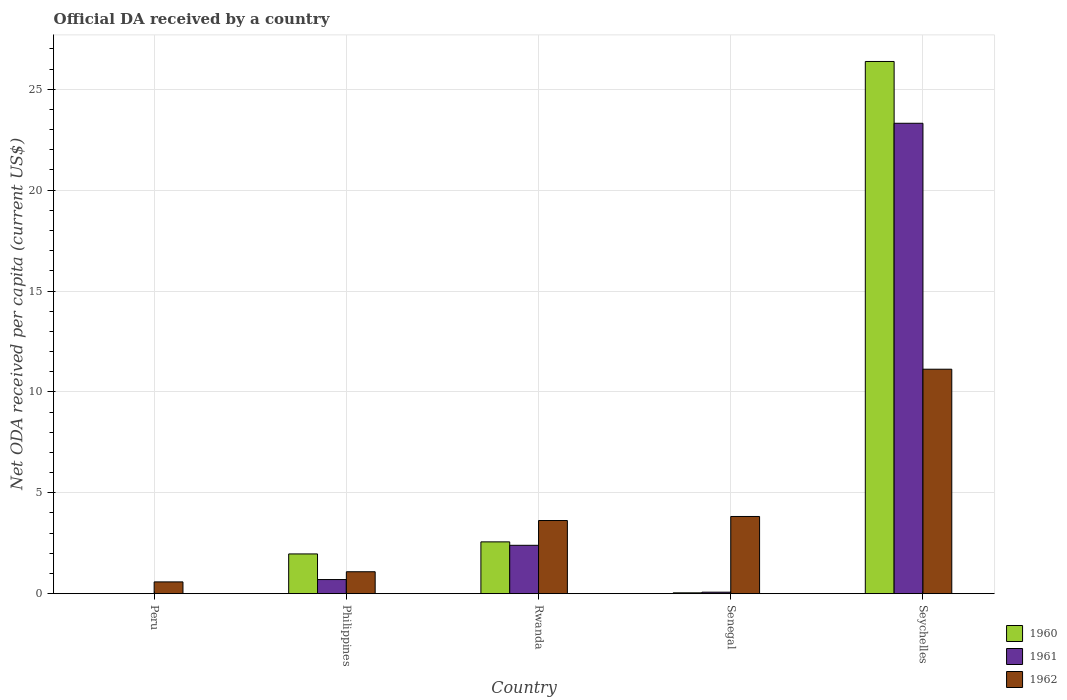How many different coloured bars are there?
Offer a very short reply. 3. What is the label of the 5th group of bars from the left?
Offer a very short reply. Seychelles. In how many cases, is the number of bars for a given country not equal to the number of legend labels?
Keep it short and to the point. 1. What is the ODA received in in 1962 in Seychelles?
Ensure brevity in your answer.  11.13. Across all countries, what is the maximum ODA received in in 1961?
Offer a very short reply. 23.32. In which country was the ODA received in in 1960 maximum?
Ensure brevity in your answer.  Seychelles. What is the total ODA received in in 1961 in the graph?
Provide a short and direct response. 26.49. What is the difference between the ODA received in in 1961 in Philippines and that in Senegal?
Your answer should be compact. 0.63. What is the difference between the ODA received in in 1961 in Senegal and the ODA received in in 1960 in Seychelles?
Your answer should be very brief. -26.31. What is the average ODA received in in 1960 per country?
Make the answer very short. 6.19. What is the difference between the ODA received in of/in 1962 and ODA received in of/in 1961 in Philippines?
Your answer should be compact. 0.39. What is the ratio of the ODA received in in 1962 in Philippines to that in Seychelles?
Offer a very short reply. 0.1. Is the difference between the ODA received in in 1962 in Philippines and Rwanda greater than the difference between the ODA received in in 1961 in Philippines and Rwanda?
Your answer should be very brief. No. What is the difference between the highest and the second highest ODA received in in 1962?
Provide a succinct answer. 0.2. What is the difference between the highest and the lowest ODA received in in 1960?
Give a very brief answer. 26.38. In how many countries, is the ODA received in in 1961 greater than the average ODA received in in 1961 taken over all countries?
Make the answer very short. 1. Is it the case that in every country, the sum of the ODA received in in 1962 and ODA received in in 1961 is greater than the ODA received in in 1960?
Give a very brief answer. No. How many bars are there?
Offer a very short reply. 13. Are all the bars in the graph horizontal?
Provide a succinct answer. No. How many countries are there in the graph?
Keep it short and to the point. 5. Does the graph contain any zero values?
Make the answer very short. Yes. Does the graph contain grids?
Ensure brevity in your answer.  Yes. Where does the legend appear in the graph?
Your response must be concise. Bottom right. How many legend labels are there?
Your response must be concise. 3. What is the title of the graph?
Make the answer very short. Official DA received by a country. What is the label or title of the Y-axis?
Keep it short and to the point. Net ODA received per capita (current US$). What is the Net ODA received per capita (current US$) of 1960 in Peru?
Offer a very short reply. 0. What is the Net ODA received per capita (current US$) of 1961 in Peru?
Keep it short and to the point. 0. What is the Net ODA received per capita (current US$) in 1962 in Peru?
Provide a short and direct response. 0.58. What is the Net ODA received per capita (current US$) in 1960 in Philippines?
Your answer should be very brief. 1.97. What is the Net ODA received per capita (current US$) of 1961 in Philippines?
Provide a short and direct response. 0.7. What is the Net ODA received per capita (current US$) in 1962 in Philippines?
Ensure brevity in your answer.  1.09. What is the Net ODA received per capita (current US$) of 1960 in Rwanda?
Ensure brevity in your answer.  2.57. What is the Net ODA received per capita (current US$) of 1961 in Rwanda?
Provide a short and direct response. 2.4. What is the Net ODA received per capita (current US$) in 1962 in Rwanda?
Your answer should be compact. 3.63. What is the Net ODA received per capita (current US$) in 1960 in Senegal?
Your response must be concise. 0.04. What is the Net ODA received per capita (current US$) of 1961 in Senegal?
Provide a succinct answer. 0.07. What is the Net ODA received per capita (current US$) of 1962 in Senegal?
Provide a succinct answer. 3.83. What is the Net ODA received per capita (current US$) in 1960 in Seychelles?
Your answer should be very brief. 26.38. What is the Net ODA received per capita (current US$) of 1961 in Seychelles?
Provide a short and direct response. 23.32. What is the Net ODA received per capita (current US$) of 1962 in Seychelles?
Your answer should be compact. 11.13. Across all countries, what is the maximum Net ODA received per capita (current US$) in 1960?
Make the answer very short. 26.38. Across all countries, what is the maximum Net ODA received per capita (current US$) of 1961?
Provide a succinct answer. 23.32. Across all countries, what is the maximum Net ODA received per capita (current US$) in 1962?
Ensure brevity in your answer.  11.13. Across all countries, what is the minimum Net ODA received per capita (current US$) in 1961?
Provide a short and direct response. 0. Across all countries, what is the minimum Net ODA received per capita (current US$) of 1962?
Keep it short and to the point. 0.58. What is the total Net ODA received per capita (current US$) of 1960 in the graph?
Your answer should be compact. 30.96. What is the total Net ODA received per capita (current US$) in 1961 in the graph?
Offer a very short reply. 26.49. What is the total Net ODA received per capita (current US$) of 1962 in the graph?
Keep it short and to the point. 20.25. What is the difference between the Net ODA received per capita (current US$) of 1962 in Peru and that in Philippines?
Ensure brevity in your answer.  -0.5. What is the difference between the Net ODA received per capita (current US$) of 1962 in Peru and that in Rwanda?
Your answer should be very brief. -3.04. What is the difference between the Net ODA received per capita (current US$) in 1962 in Peru and that in Senegal?
Provide a short and direct response. -3.24. What is the difference between the Net ODA received per capita (current US$) of 1962 in Peru and that in Seychelles?
Your response must be concise. -10.54. What is the difference between the Net ODA received per capita (current US$) in 1960 in Philippines and that in Rwanda?
Provide a short and direct response. -0.6. What is the difference between the Net ODA received per capita (current US$) of 1961 in Philippines and that in Rwanda?
Ensure brevity in your answer.  -1.7. What is the difference between the Net ODA received per capita (current US$) in 1962 in Philippines and that in Rwanda?
Your response must be concise. -2.54. What is the difference between the Net ODA received per capita (current US$) of 1960 in Philippines and that in Senegal?
Provide a short and direct response. 1.93. What is the difference between the Net ODA received per capita (current US$) of 1961 in Philippines and that in Senegal?
Your answer should be compact. 0.63. What is the difference between the Net ODA received per capita (current US$) in 1962 in Philippines and that in Senegal?
Offer a very short reply. -2.74. What is the difference between the Net ODA received per capita (current US$) of 1960 in Philippines and that in Seychelles?
Offer a very short reply. -24.41. What is the difference between the Net ODA received per capita (current US$) in 1961 in Philippines and that in Seychelles?
Provide a short and direct response. -22.62. What is the difference between the Net ODA received per capita (current US$) in 1962 in Philippines and that in Seychelles?
Provide a succinct answer. -10.04. What is the difference between the Net ODA received per capita (current US$) of 1960 in Rwanda and that in Senegal?
Your answer should be compact. 2.53. What is the difference between the Net ODA received per capita (current US$) in 1961 in Rwanda and that in Senegal?
Make the answer very short. 2.32. What is the difference between the Net ODA received per capita (current US$) of 1962 in Rwanda and that in Senegal?
Make the answer very short. -0.2. What is the difference between the Net ODA received per capita (current US$) of 1960 in Rwanda and that in Seychelles?
Ensure brevity in your answer.  -23.81. What is the difference between the Net ODA received per capita (current US$) in 1961 in Rwanda and that in Seychelles?
Give a very brief answer. -20.92. What is the difference between the Net ODA received per capita (current US$) in 1962 in Rwanda and that in Seychelles?
Provide a short and direct response. -7.5. What is the difference between the Net ODA received per capita (current US$) of 1960 in Senegal and that in Seychelles?
Provide a succinct answer. -26.34. What is the difference between the Net ODA received per capita (current US$) in 1961 in Senegal and that in Seychelles?
Make the answer very short. -23.24. What is the difference between the Net ODA received per capita (current US$) of 1962 in Senegal and that in Seychelles?
Offer a very short reply. -7.3. What is the difference between the Net ODA received per capita (current US$) of 1960 in Philippines and the Net ODA received per capita (current US$) of 1961 in Rwanda?
Your response must be concise. -0.43. What is the difference between the Net ODA received per capita (current US$) of 1960 in Philippines and the Net ODA received per capita (current US$) of 1962 in Rwanda?
Your answer should be very brief. -1.66. What is the difference between the Net ODA received per capita (current US$) of 1961 in Philippines and the Net ODA received per capita (current US$) of 1962 in Rwanda?
Provide a succinct answer. -2.93. What is the difference between the Net ODA received per capita (current US$) in 1960 in Philippines and the Net ODA received per capita (current US$) in 1961 in Senegal?
Provide a short and direct response. 1.9. What is the difference between the Net ODA received per capita (current US$) in 1960 in Philippines and the Net ODA received per capita (current US$) in 1962 in Senegal?
Your answer should be very brief. -1.86. What is the difference between the Net ODA received per capita (current US$) in 1961 in Philippines and the Net ODA received per capita (current US$) in 1962 in Senegal?
Offer a very short reply. -3.13. What is the difference between the Net ODA received per capita (current US$) in 1960 in Philippines and the Net ODA received per capita (current US$) in 1961 in Seychelles?
Your answer should be compact. -21.35. What is the difference between the Net ODA received per capita (current US$) in 1960 in Philippines and the Net ODA received per capita (current US$) in 1962 in Seychelles?
Offer a very short reply. -9.16. What is the difference between the Net ODA received per capita (current US$) in 1961 in Philippines and the Net ODA received per capita (current US$) in 1962 in Seychelles?
Offer a very short reply. -10.43. What is the difference between the Net ODA received per capita (current US$) in 1960 in Rwanda and the Net ODA received per capita (current US$) in 1961 in Senegal?
Your answer should be compact. 2.49. What is the difference between the Net ODA received per capita (current US$) in 1960 in Rwanda and the Net ODA received per capita (current US$) in 1962 in Senegal?
Provide a succinct answer. -1.26. What is the difference between the Net ODA received per capita (current US$) in 1961 in Rwanda and the Net ODA received per capita (current US$) in 1962 in Senegal?
Offer a very short reply. -1.43. What is the difference between the Net ODA received per capita (current US$) of 1960 in Rwanda and the Net ODA received per capita (current US$) of 1961 in Seychelles?
Make the answer very short. -20.75. What is the difference between the Net ODA received per capita (current US$) in 1960 in Rwanda and the Net ODA received per capita (current US$) in 1962 in Seychelles?
Your answer should be compact. -8.56. What is the difference between the Net ODA received per capita (current US$) in 1961 in Rwanda and the Net ODA received per capita (current US$) in 1962 in Seychelles?
Give a very brief answer. -8.73. What is the difference between the Net ODA received per capita (current US$) of 1960 in Senegal and the Net ODA received per capita (current US$) of 1961 in Seychelles?
Offer a very short reply. -23.28. What is the difference between the Net ODA received per capita (current US$) of 1960 in Senegal and the Net ODA received per capita (current US$) of 1962 in Seychelles?
Your response must be concise. -11.08. What is the difference between the Net ODA received per capita (current US$) of 1961 in Senegal and the Net ODA received per capita (current US$) of 1962 in Seychelles?
Provide a short and direct response. -11.05. What is the average Net ODA received per capita (current US$) in 1960 per country?
Provide a succinct answer. 6.19. What is the average Net ODA received per capita (current US$) in 1961 per country?
Provide a succinct answer. 5.3. What is the average Net ODA received per capita (current US$) of 1962 per country?
Give a very brief answer. 4.05. What is the difference between the Net ODA received per capita (current US$) in 1960 and Net ODA received per capita (current US$) in 1961 in Philippines?
Your answer should be very brief. 1.27. What is the difference between the Net ODA received per capita (current US$) of 1960 and Net ODA received per capita (current US$) of 1962 in Philippines?
Provide a short and direct response. 0.88. What is the difference between the Net ODA received per capita (current US$) of 1961 and Net ODA received per capita (current US$) of 1962 in Philippines?
Offer a very short reply. -0.39. What is the difference between the Net ODA received per capita (current US$) in 1960 and Net ODA received per capita (current US$) in 1961 in Rwanda?
Offer a very short reply. 0.17. What is the difference between the Net ODA received per capita (current US$) in 1960 and Net ODA received per capita (current US$) in 1962 in Rwanda?
Give a very brief answer. -1.06. What is the difference between the Net ODA received per capita (current US$) in 1961 and Net ODA received per capita (current US$) in 1962 in Rwanda?
Your response must be concise. -1.23. What is the difference between the Net ODA received per capita (current US$) of 1960 and Net ODA received per capita (current US$) of 1961 in Senegal?
Make the answer very short. -0.03. What is the difference between the Net ODA received per capita (current US$) in 1960 and Net ODA received per capita (current US$) in 1962 in Senegal?
Make the answer very short. -3.78. What is the difference between the Net ODA received per capita (current US$) in 1961 and Net ODA received per capita (current US$) in 1962 in Senegal?
Ensure brevity in your answer.  -3.75. What is the difference between the Net ODA received per capita (current US$) of 1960 and Net ODA received per capita (current US$) of 1961 in Seychelles?
Offer a very short reply. 3.06. What is the difference between the Net ODA received per capita (current US$) of 1960 and Net ODA received per capita (current US$) of 1962 in Seychelles?
Your answer should be very brief. 15.25. What is the difference between the Net ODA received per capita (current US$) in 1961 and Net ODA received per capita (current US$) in 1962 in Seychelles?
Your answer should be compact. 12.19. What is the ratio of the Net ODA received per capita (current US$) in 1962 in Peru to that in Philippines?
Provide a succinct answer. 0.54. What is the ratio of the Net ODA received per capita (current US$) in 1962 in Peru to that in Rwanda?
Provide a succinct answer. 0.16. What is the ratio of the Net ODA received per capita (current US$) in 1962 in Peru to that in Senegal?
Your response must be concise. 0.15. What is the ratio of the Net ODA received per capita (current US$) of 1962 in Peru to that in Seychelles?
Your answer should be compact. 0.05. What is the ratio of the Net ODA received per capita (current US$) in 1960 in Philippines to that in Rwanda?
Provide a short and direct response. 0.77. What is the ratio of the Net ODA received per capita (current US$) in 1961 in Philippines to that in Rwanda?
Offer a very short reply. 0.29. What is the ratio of the Net ODA received per capita (current US$) in 1962 in Philippines to that in Rwanda?
Provide a succinct answer. 0.3. What is the ratio of the Net ODA received per capita (current US$) in 1960 in Philippines to that in Senegal?
Ensure brevity in your answer.  48.13. What is the ratio of the Net ODA received per capita (current US$) of 1961 in Philippines to that in Senegal?
Provide a short and direct response. 9.52. What is the ratio of the Net ODA received per capita (current US$) in 1962 in Philippines to that in Senegal?
Your answer should be very brief. 0.28. What is the ratio of the Net ODA received per capita (current US$) of 1960 in Philippines to that in Seychelles?
Keep it short and to the point. 0.07. What is the ratio of the Net ODA received per capita (current US$) of 1961 in Philippines to that in Seychelles?
Provide a succinct answer. 0.03. What is the ratio of the Net ODA received per capita (current US$) of 1962 in Philippines to that in Seychelles?
Your answer should be very brief. 0.1. What is the ratio of the Net ODA received per capita (current US$) of 1960 in Rwanda to that in Senegal?
Your answer should be compact. 62.74. What is the ratio of the Net ODA received per capita (current US$) in 1961 in Rwanda to that in Senegal?
Offer a terse response. 32.61. What is the ratio of the Net ODA received per capita (current US$) in 1962 in Rwanda to that in Senegal?
Give a very brief answer. 0.95. What is the ratio of the Net ODA received per capita (current US$) of 1960 in Rwanda to that in Seychelles?
Make the answer very short. 0.1. What is the ratio of the Net ODA received per capita (current US$) in 1961 in Rwanda to that in Seychelles?
Offer a terse response. 0.1. What is the ratio of the Net ODA received per capita (current US$) of 1962 in Rwanda to that in Seychelles?
Give a very brief answer. 0.33. What is the ratio of the Net ODA received per capita (current US$) of 1960 in Senegal to that in Seychelles?
Ensure brevity in your answer.  0. What is the ratio of the Net ODA received per capita (current US$) in 1961 in Senegal to that in Seychelles?
Your response must be concise. 0. What is the ratio of the Net ODA received per capita (current US$) in 1962 in Senegal to that in Seychelles?
Your answer should be very brief. 0.34. What is the difference between the highest and the second highest Net ODA received per capita (current US$) of 1960?
Provide a succinct answer. 23.81. What is the difference between the highest and the second highest Net ODA received per capita (current US$) of 1961?
Keep it short and to the point. 20.92. What is the difference between the highest and the second highest Net ODA received per capita (current US$) of 1962?
Provide a short and direct response. 7.3. What is the difference between the highest and the lowest Net ODA received per capita (current US$) of 1960?
Your answer should be very brief. 26.38. What is the difference between the highest and the lowest Net ODA received per capita (current US$) of 1961?
Ensure brevity in your answer.  23.32. What is the difference between the highest and the lowest Net ODA received per capita (current US$) of 1962?
Your answer should be very brief. 10.54. 